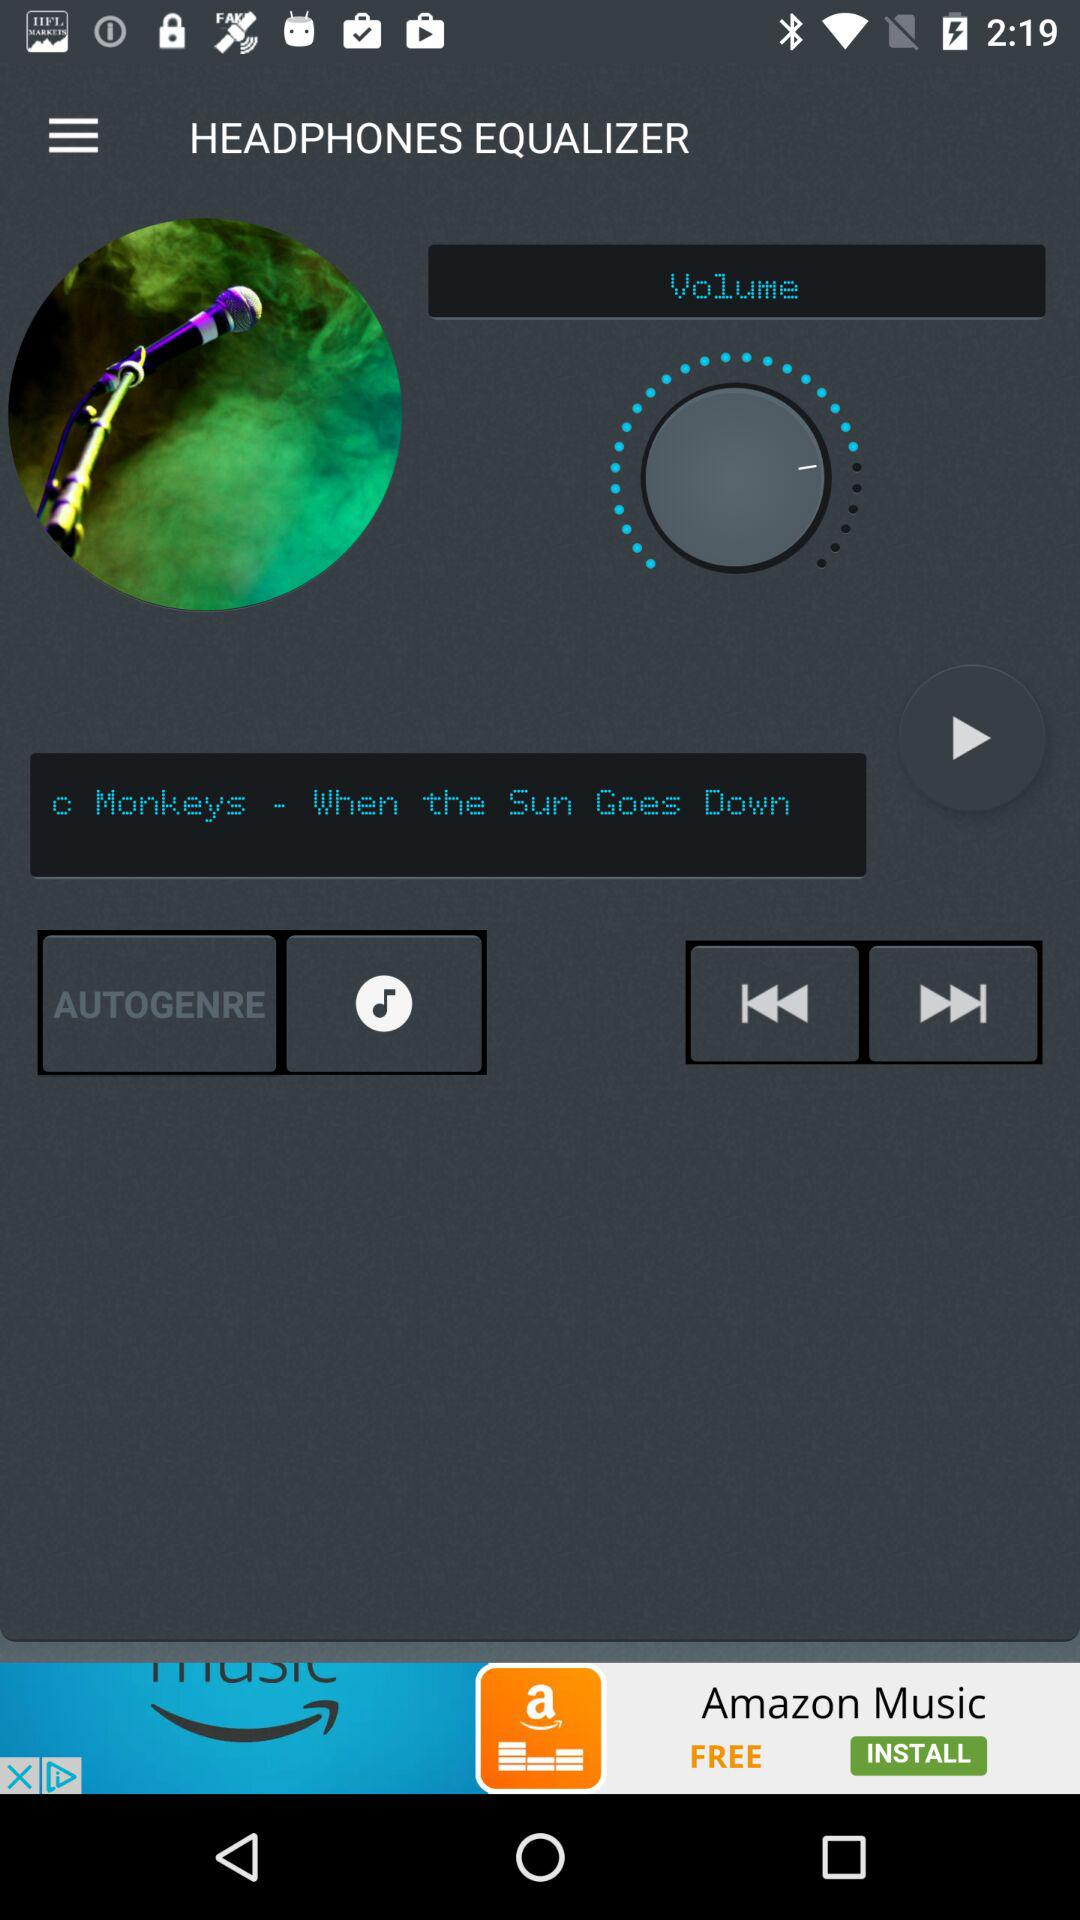Which song is playing? The song is "When the Sun Goes Down". 